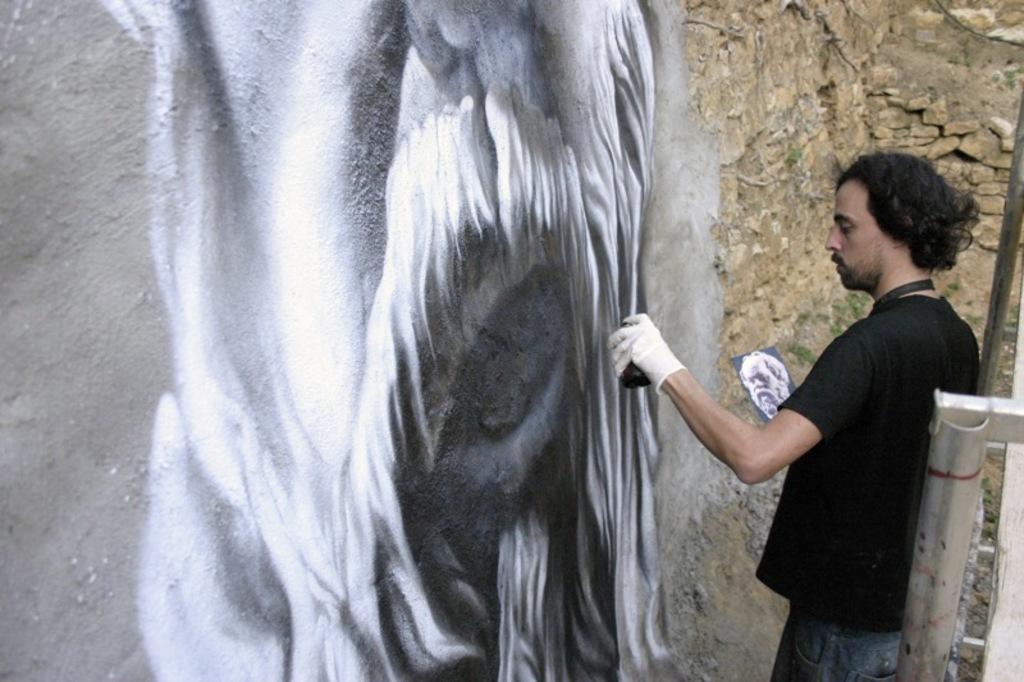Please provide a concise description of this image. In this image there is a man who is painting the picture on the wall by using the spray. He is holding the picture with one hand. On the right side there is a metal rod. 